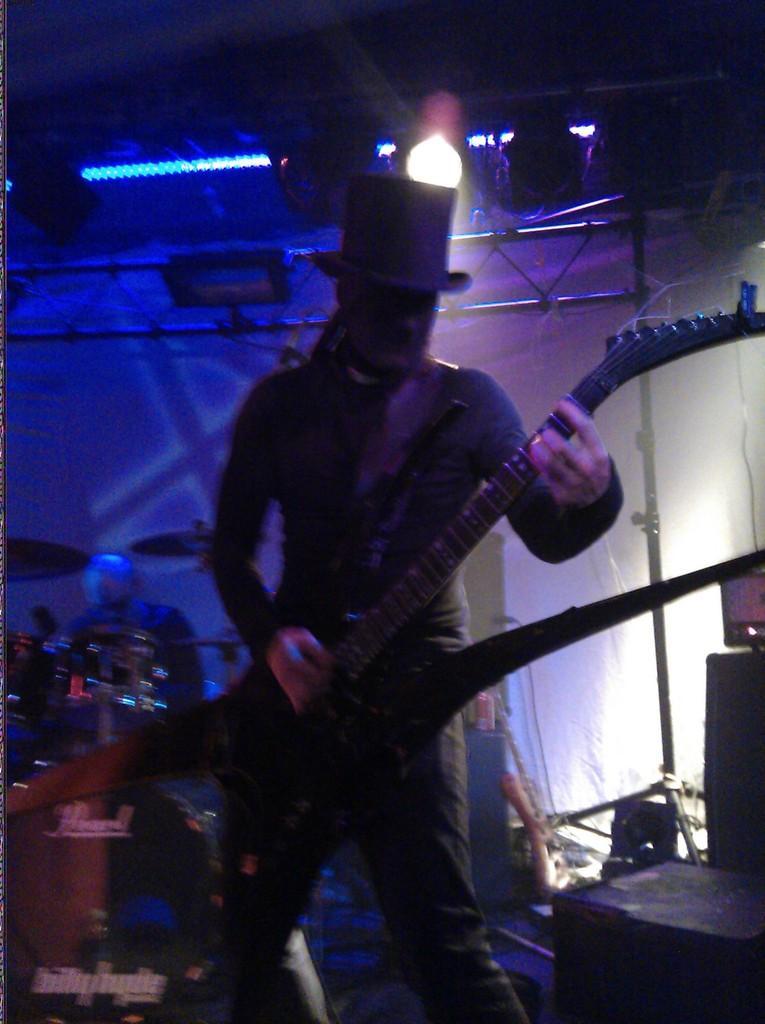How would you summarize this image in a sentence or two? In this image I can see a person wearing the hat and holding the mobile. In the background there is a drum set and the light. 